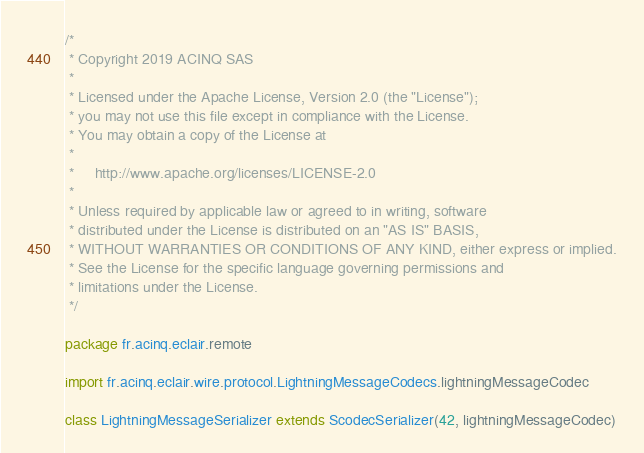Convert code to text. <code><loc_0><loc_0><loc_500><loc_500><_Scala_>/*
 * Copyright 2019 ACINQ SAS
 *
 * Licensed under the Apache License, Version 2.0 (the "License");
 * you may not use this file except in compliance with the License.
 * You may obtain a copy of the License at
 *
 *     http://www.apache.org/licenses/LICENSE-2.0
 *
 * Unless required by applicable law or agreed to in writing, software
 * distributed under the License is distributed on an "AS IS" BASIS,
 * WITHOUT WARRANTIES OR CONDITIONS OF ANY KIND, either express or implied.
 * See the License for the specific language governing permissions and
 * limitations under the License.
 */

package fr.acinq.eclair.remote

import fr.acinq.eclair.wire.protocol.LightningMessageCodecs.lightningMessageCodec

class LightningMessageSerializer extends ScodecSerializer(42, lightningMessageCodec)</code> 